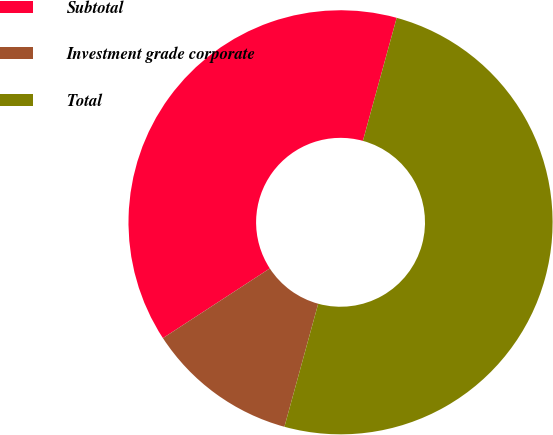Convert chart. <chart><loc_0><loc_0><loc_500><loc_500><pie_chart><fcel>Subtotal<fcel>Investment grade corporate<fcel>Total<nl><fcel>38.46%<fcel>11.54%<fcel>50.0%<nl></chart> 